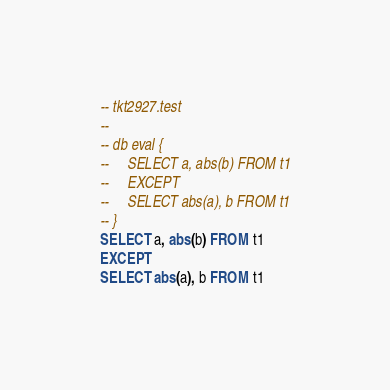Convert code to text. <code><loc_0><loc_0><loc_500><loc_500><_SQL_>-- tkt2927.test
-- 
-- db eval {
--     SELECT a, abs(b) FROM t1
--     EXCEPT
--     SELECT abs(a), b FROM t1
-- }
SELECT a, abs(b) FROM t1
EXCEPT
SELECT abs(a), b FROM t1</code> 